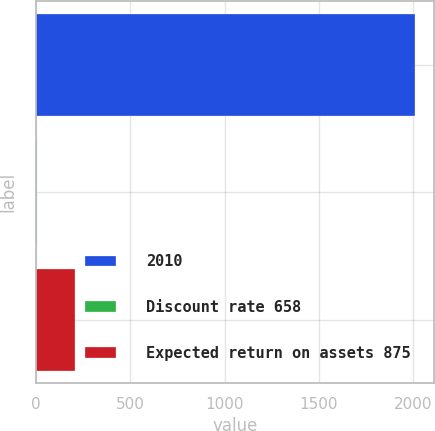Convert chart to OTSL. <chart><loc_0><loc_0><loc_500><loc_500><bar_chart><fcel>2010<fcel>Discount rate 658<fcel>Expected return on assets 875<nl><fcel>2010<fcel>5.84<fcel>206.26<nl></chart> 